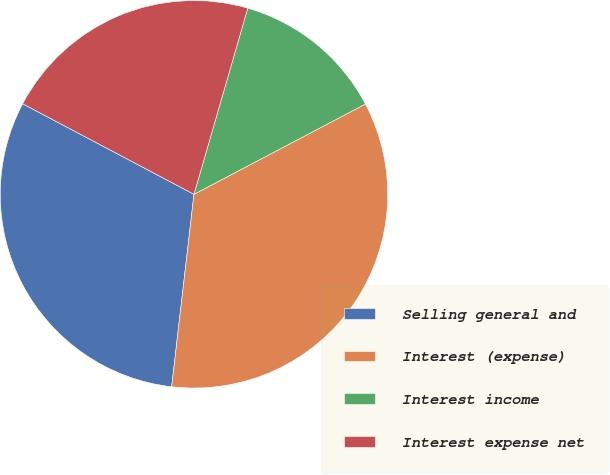<chart> <loc_0><loc_0><loc_500><loc_500><pie_chart><fcel>Selling general and<fcel>Interest (expense)<fcel>Interest income<fcel>Interest expense net<nl><fcel>30.9%<fcel>34.55%<fcel>12.81%<fcel>21.74%<nl></chart> 